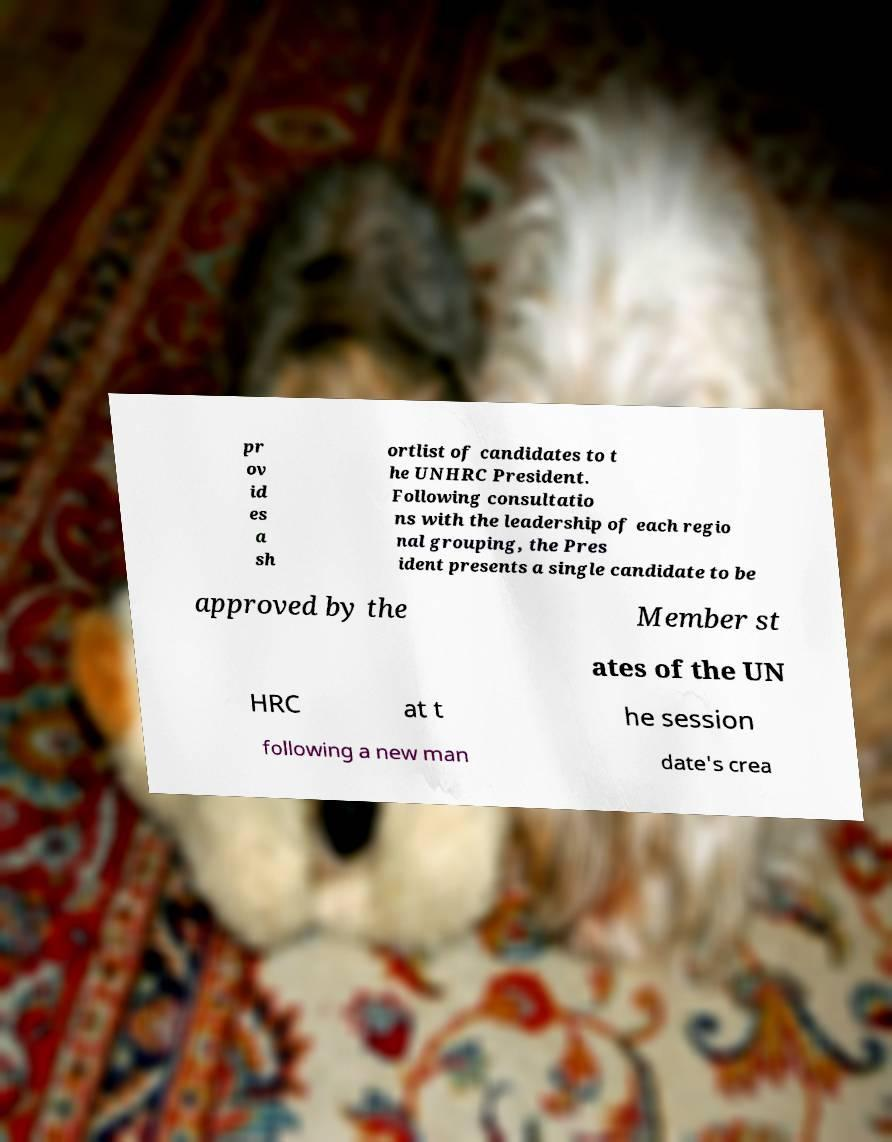Can you accurately transcribe the text from the provided image for me? pr ov id es a sh ortlist of candidates to t he UNHRC President. Following consultatio ns with the leadership of each regio nal grouping, the Pres ident presents a single candidate to be approved by the Member st ates of the UN HRC at t he session following a new man date's crea 